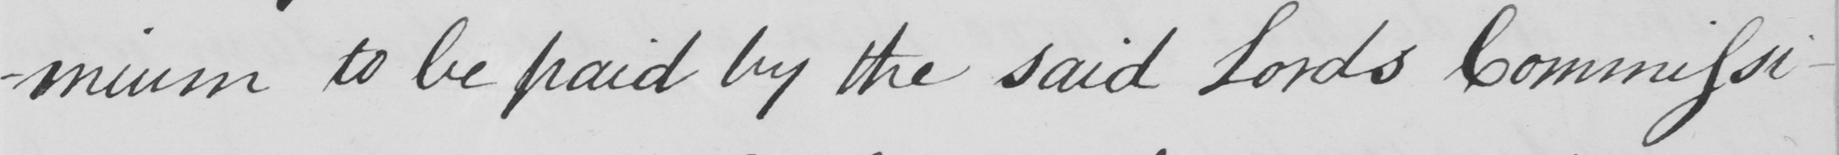What does this handwritten line say? -mium to be paid by the said Lords Commissi- 